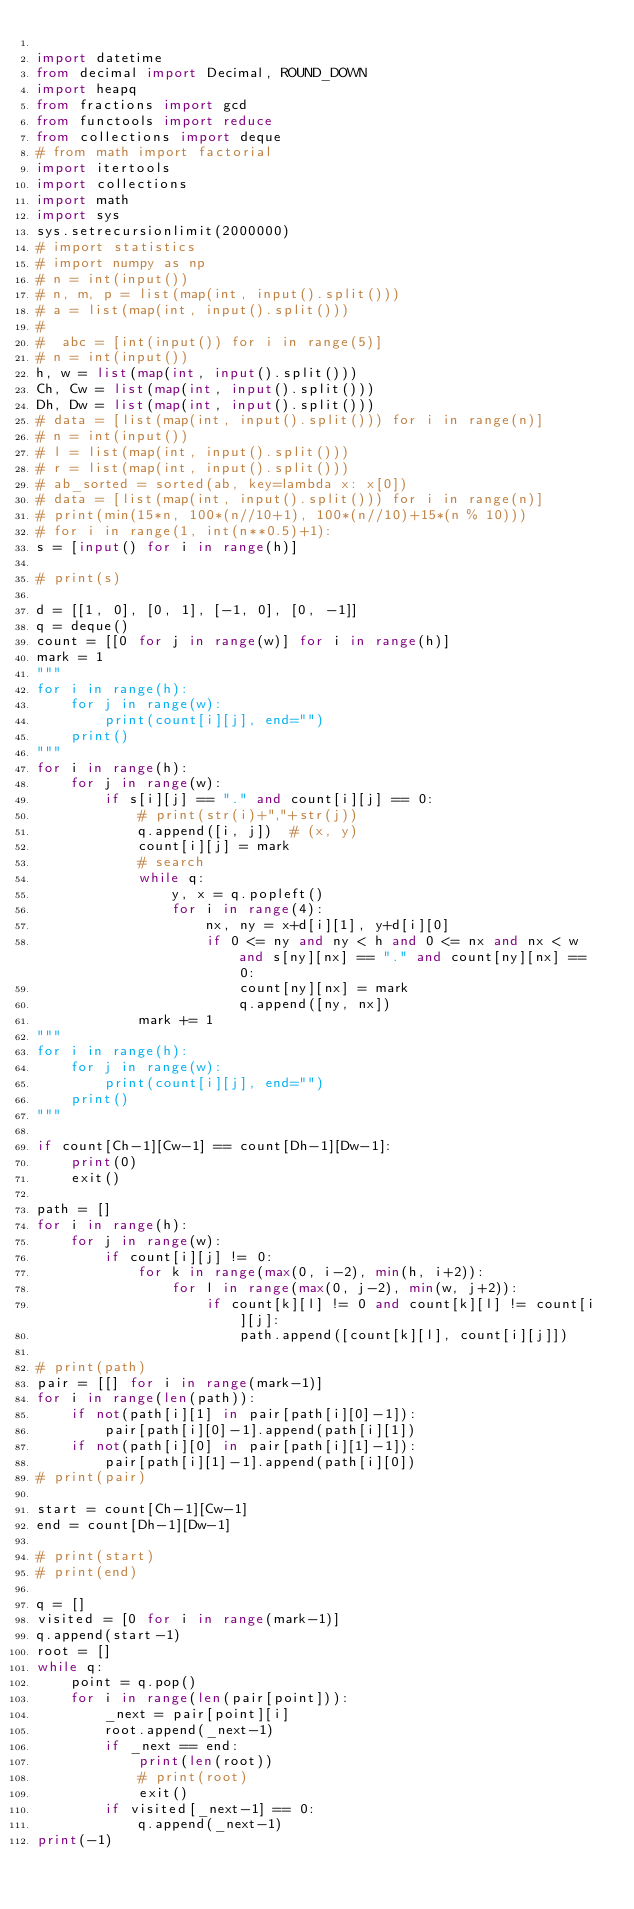Convert code to text. <code><loc_0><loc_0><loc_500><loc_500><_Python_>
import datetime
from decimal import Decimal, ROUND_DOWN
import heapq
from fractions import gcd
from functools import reduce
from collections import deque
# from math import factorial
import itertools
import collections
import math
import sys
sys.setrecursionlimit(2000000)
# import statistics
# import numpy as np
# n = int(input())
# n, m, p = list(map(int, input().split()))
# a = list(map(int, input().split()))
#
#  abc = [int(input()) for i in range(5)]
# n = int(input())
h, w = list(map(int, input().split()))
Ch, Cw = list(map(int, input().split()))
Dh, Dw = list(map(int, input().split()))
# data = [list(map(int, input().split())) for i in range(n)]
# n = int(input())
# l = list(map(int, input().split()))
# r = list(map(int, input().split()))
# ab_sorted = sorted(ab, key=lambda x: x[0])
# data = [list(map(int, input().split())) for i in range(n)]
# print(min(15*n, 100*(n//10+1), 100*(n//10)+15*(n % 10)))
# for i in range(1, int(n**0.5)+1):
s = [input() for i in range(h)]

# print(s)

d = [[1, 0], [0, 1], [-1, 0], [0, -1]]
q = deque()
count = [[0 for j in range(w)] for i in range(h)]
mark = 1
"""
for i in range(h):
    for j in range(w):
        print(count[i][j], end="")
    print()
"""
for i in range(h):
    for j in range(w):
        if s[i][j] == "." and count[i][j] == 0:
            # print(str(i)+","+str(j))
            q.append([i, j])  # (x, y)
            count[i][j] = mark
            # search
            while q:
                y, x = q.popleft()
                for i in range(4):
                    nx, ny = x+d[i][1], y+d[i][0]
                    if 0 <= ny and ny < h and 0 <= nx and nx < w and s[ny][nx] == "." and count[ny][nx] == 0:
                        count[ny][nx] = mark
                        q.append([ny, nx])
            mark += 1
"""
for i in range(h):
    for j in range(w):
        print(count[i][j], end="")
    print()
"""

if count[Ch-1][Cw-1] == count[Dh-1][Dw-1]:
    print(0)
    exit()

path = []
for i in range(h):
    for j in range(w):
        if count[i][j] != 0:
            for k in range(max(0, i-2), min(h, i+2)):
                for l in range(max(0, j-2), min(w, j+2)):
                    if count[k][l] != 0 and count[k][l] != count[i][j]:
                        path.append([count[k][l], count[i][j]])

# print(path)
pair = [[] for i in range(mark-1)]
for i in range(len(path)):
    if not(path[i][1] in pair[path[i][0]-1]):
        pair[path[i][0]-1].append(path[i][1])
    if not(path[i][0] in pair[path[i][1]-1]):
        pair[path[i][1]-1].append(path[i][0])
# print(pair)

start = count[Ch-1][Cw-1]
end = count[Dh-1][Dw-1]

# print(start)
# print(end)

q = []
visited = [0 for i in range(mark-1)]
q.append(start-1)
root = []
while q:
    point = q.pop()
    for i in range(len(pair[point])):
        _next = pair[point][i]
        root.append(_next-1)
        if _next == end:
            print(len(root))
            # print(root)
            exit()
        if visited[_next-1] == 0:
            q.append(_next-1)
print(-1)

</code> 